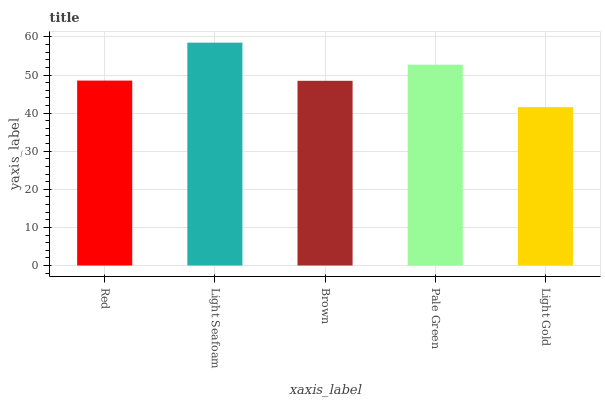Is Brown the minimum?
Answer yes or no. No. Is Brown the maximum?
Answer yes or no. No. Is Light Seafoam greater than Brown?
Answer yes or no. Yes. Is Brown less than Light Seafoam?
Answer yes or no. Yes. Is Brown greater than Light Seafoam?
Answer yes or no. No. Is Light Seafoam less than Brown?
Answer yes or no. No. Is Red the high median?
Answer yes or no. Yes. Is Red the low median?
Answer yes or no. Yes. Is Light Seafoam the high median?
Answer yes or no. No. Is Light Gold the low median?
Answer yes or no. No. 